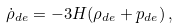<formula> <loc_0><loc_0><loc_500><loc_500>\dot { \rho } _ { d e } = - 3 H ( \rho _ { d e } + p _ { d e } ) \, ,</formula> 